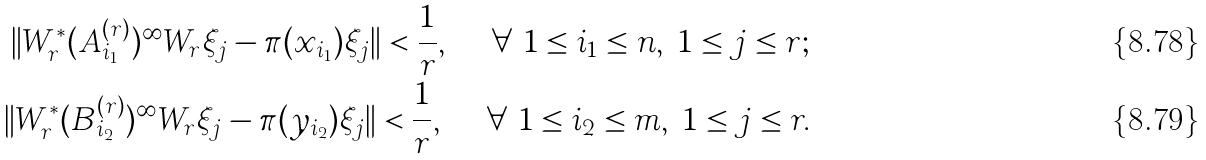Convert formula to latex. <formula><loc_0><loc_0><loc_500><loc_500>\| W _ { r } ^ { * } ( A _ { i _ { 1 } } ^ { ( r ) } ) ^ { \infty } W _ { r } \xi _ { j } - \pi ( x _ { i _ { 1 } } ) \xi _ { j } \| < \frac { 1 } { r } , \quad \ \forall \ 1 \leq i _ { 1 } \leq n , \ 1 \leq j \leq r ; \\ \| W _ { r } ^ { * } ( B _ { i _ { 2 } } ^ { ( r ) } ) ^ { \infty } W _ { r } \xi _ { j } - \pi ( y _ { i _ { 2 } } ) \xi _ { j } \| < \frac { 1 } { r } , \quad \ \forall \ 1 \leq i _ { 2 } \leq m , \ 1 \leq j \leq r .</formula> 